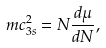<formula> <loc_0><loc_0><loc_500><loc_500>m c _ { 3 s } ^ { 2 } = N \frac { d \mu } { d N } ,</formula> 